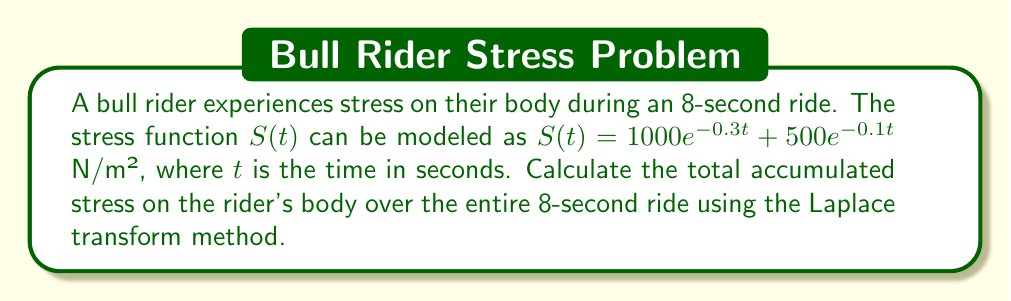Give your solution to this math problem. To solve this problem, we'll follow these steps:

1) First, we need to find the Laplace transform of the stress function $S(t)$:

   $\mathcal{L}\{S(t)\} = \mathcal{L}\{1000e^{-0.3t} + 500e^{-0.1t}\}$

2) Using the linearity property of Laplace transforms:

   $\mathcal{L}\{S(t)\} = 1000\mathcal{L}\{e^{-0.3t}\} + 500\mathcal{L}\{e^{-0.1t}\}$

3) The Laplace transform of $e^{-at}$ is $\frac{1}{s+a}$, so:

   $\mathcal{L}\{S(t)\} = \frac{1000}{s+0.3} + \frac{500}{s+0.1}$

4) To find the total accumulated stress, we need to integrate $S(t)$ from 0 to 8. In the Laplace domain, this is equivalent to dividing by $s$ and then evaluating at $t=8$:

   $\int_0^8 S(t) dt = \mathcal{L}^{-1}\left\{\frac{1}{s}\left(\frac{1000}{s+0.3} + \frac{500}{s+0.1}\right)\right\}\bigg|_{t=8}$

5) Using partial fractions decomposition:

   $\frac{1}{s}\left(\frac{1000}{s+0.3} + \frac{500}{s+0.1}\right) = \frac{1000}{0.3s} - \frac{1000}{0.3(s+0.3)} + \frac{500}{0.1s} - \frac{500}{0.1(s+0.1)}$

6) Taking the inverse Laplace transform:

   $\mathcal{L}^{-1}\left\{\frac{1000}{0.3s} - \frac{1000}{0.3(s+0.3)} + \frac{500}{0.1s} - \frac{500}{0.1(s+0.1)}\right\}$
   $= \frac{1000}{0.3} - \frac{1000}{0.3}e^{-0.3t} + \frac{500}{0.1} - \frac{500}{0.1}e^{-0.1t}$

7) Evaluating at $t=8$:

   $\int_0^8 S(t) dt = \left(\frac{1000}{0.3} - \frac{1000}{0.3}e^{-0.3(8)} + \frac{500}{0.1} - \frac{500}{0.1}e^{-0.1(8)}\right)$

8) Calculating the final result:

   $\int_0^8 S(t) dt = 3333.33 - 3333.33 \cdot 0.0907 + 5000 - 5000 \cdot 0.4493$
                     $= 3333.33 - 302.33 + 5000 - 2246.5$
                     $= 5784.5$ N·s/m²
Answer: The total accumulated stress on the bull rider's body over the 8-second ride is approximately 5784.5 N·s/m². 